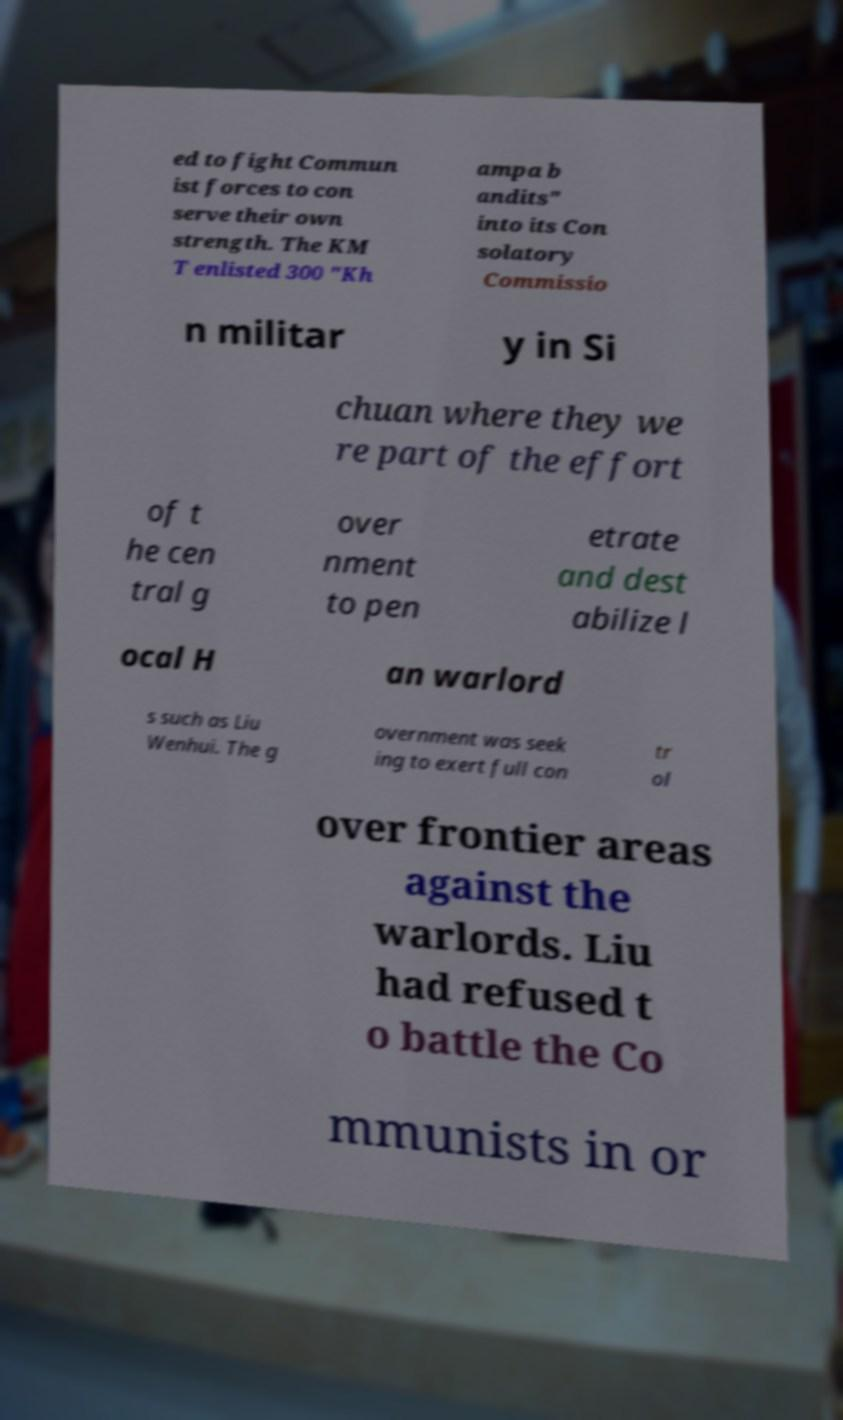What messages or text are displayed in this image? I need them in a readable, typed format. ed to fight Commun ist forces to con serve their own strength. The KM T enlisted 300 "Kh ampa b andits" into its Con solatory Commissio n militar y in Si chuan where they we re part of the effort of t he cen tral g over nment to pen etrate and dest abilize l ocal H an warlord s such as Liu Wenhui. The g overnment was seek ing to exert full con tr ol over frontier areas against the warlords. Liu had refused t o battle the Co mmunists in or 